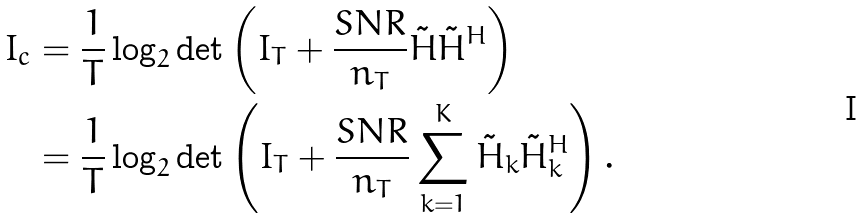Convert formula to latex. <formula><loc_0><loc_0><loc_500><loc_500>I _ { c } & = \frac { 1 } { T } \log _ { 2 } \det \left ( I _ { T } + \frac { S N R } { n _ { T } } \tilde { H } \tilde { H } ^ { H } \right ) \\ & = \frac { 1 } { T } \log _ { 2 } \det \left ( I _ { T } + \frac { S N R } { n _ { T } } \sum _ { k = 1 } ^ { K } \tilde { H } _ { k } \tilde { H } _ { k } ^ { H } \right ) .</formula> 